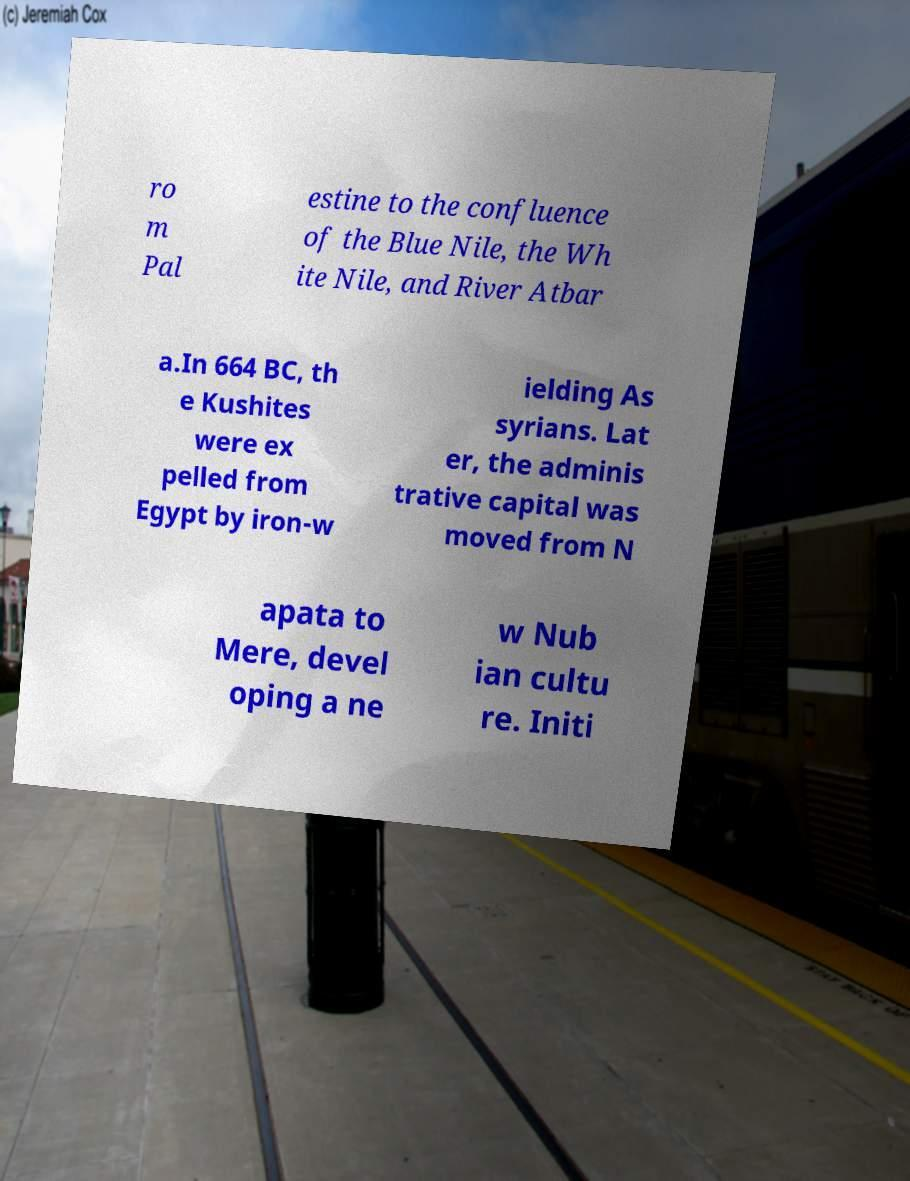Could you extract and type out the text from this image? ro m Pal estine to the confluence of the Blue Nile, the Wh ite Nile, and River Atbar a.In 664 BC, th e Kushites were ex pelled from Egypt by iron-w ielding As syrians. Lat er, the adminis trative capital was moved from N apata to Mere, devel oping a ne w Nub ian cultu re. Initi 